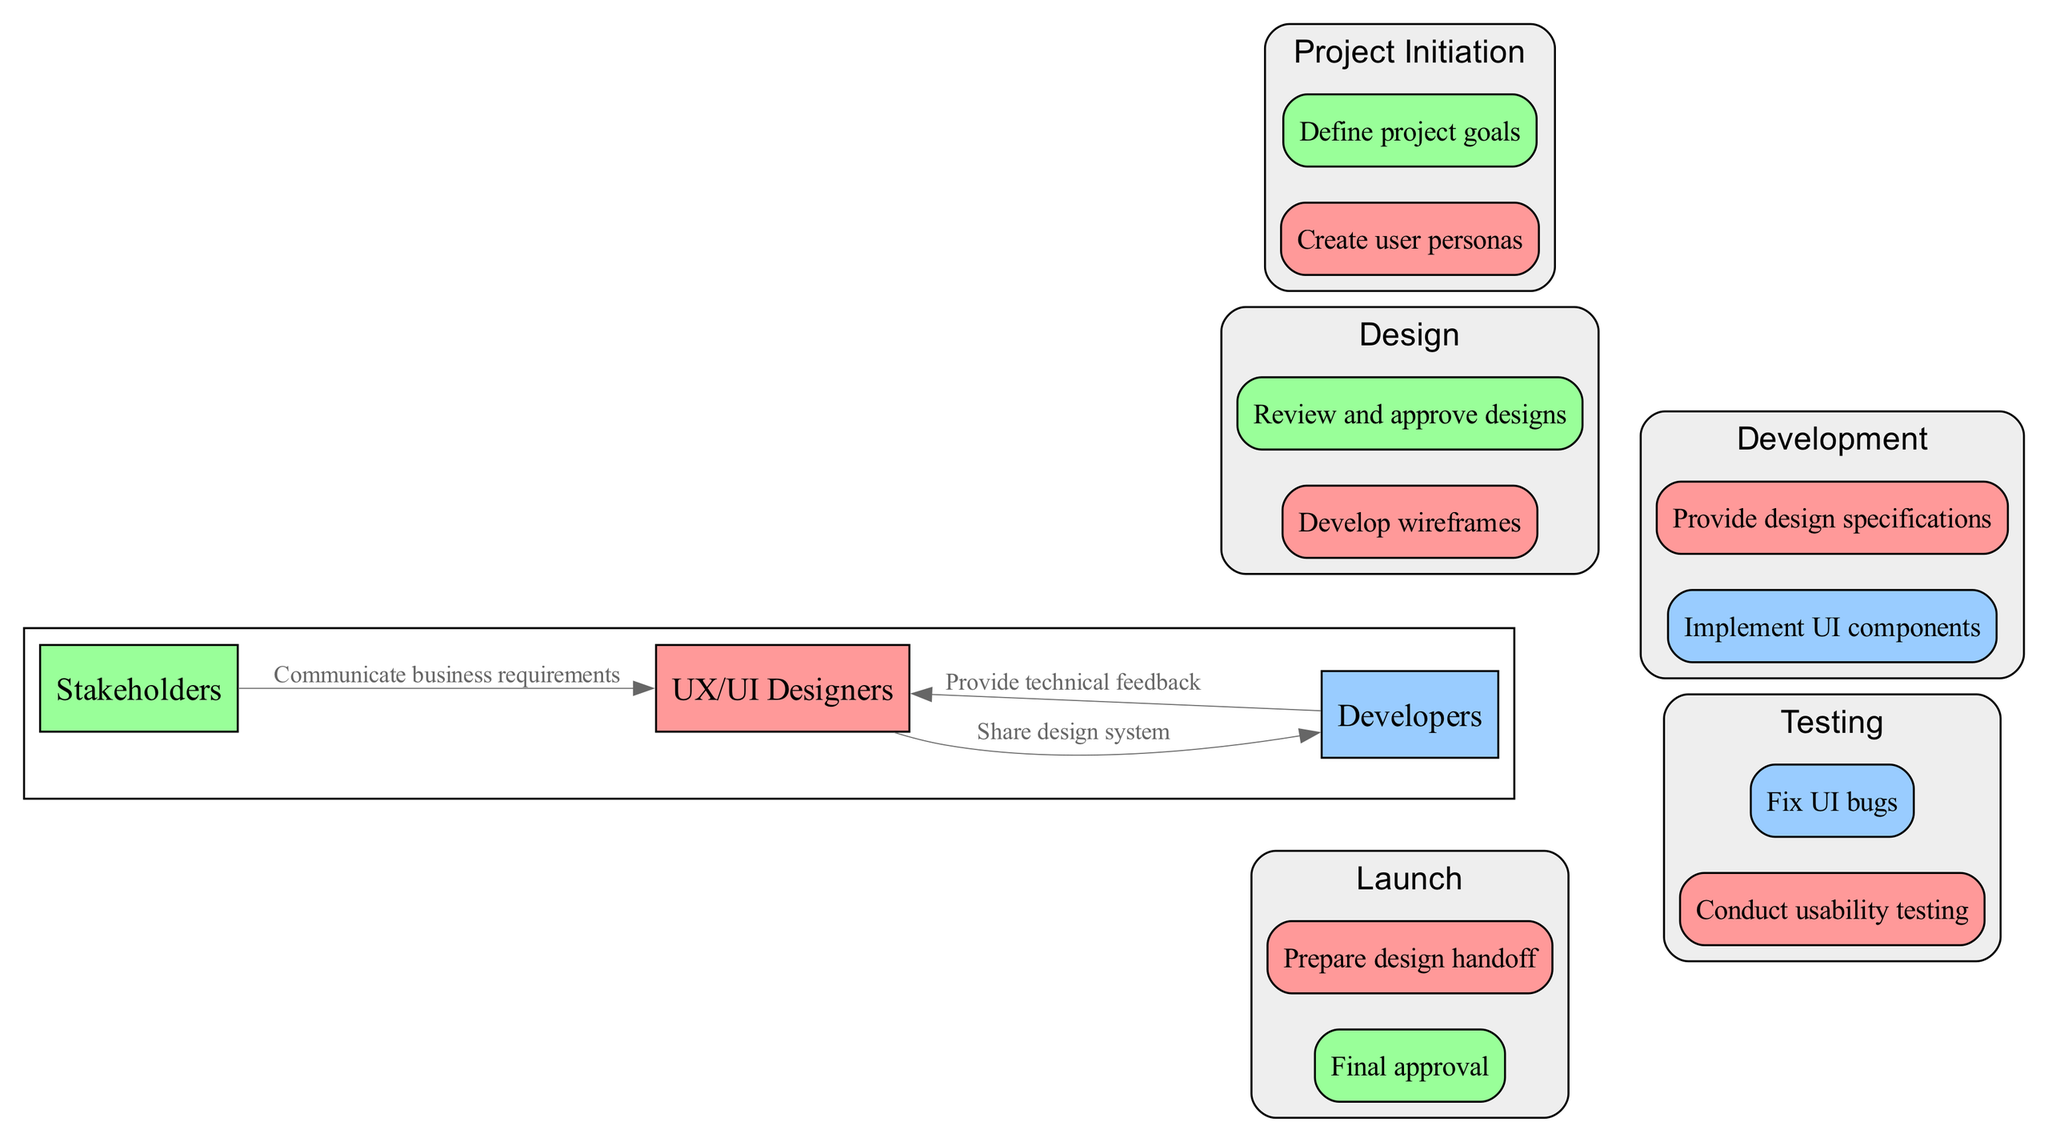What task is associated with the "Design" phase for UX/UI Designers? According to the diagram, the task associated with the "Design" phase for UX/UI Designers is "Develop wireframes," as it is listed under the tasks for that phase and lane.
Answer: Develop wireframes Who defines the project goals during the "Project Initiation" phase? The diagram indicates that "Stakeholders" are responsible for defining project goals in the "Project Initiation" phase, as they have a task specifically for this in that phase.
Answer: Stakeholders What action do UX/UI Designers take towards Developers during the Development phase? The diagram shows that UX/UI Designers share the design system with Developers during the Development phase, as indicated by the collaboration labeled between those two roles.
Answer: Share design system How many tasks are listed for the "Testing" phase? In the diagram, there are two tasks listed for the "Testing" phase: "Conduct usability testing" (by UX/UI Designers) and "Fix UI bugs" (by Developers). Thus, counting these tasks gives a total of two.
Answer: 2 Which team reviews and approves designs in the Design phase? Based on the diagram, the team that reviews and approves designs in the Design phase is "Stakeholders," as this task is explicitly assigned to them for this phase.
Answer: Stakeholders What is the last task performed before the Launch phase? Looking at the diagram, the last task performed before the Launch phase is "Conduct usability testing," as it is situated at the end of the Testing phase.
Answer: Conduct usability testing What is the connection between Stakeholders and UX/UI Designers regarding business requirements? The diagram represents a collaboration where Stakeholders communicate business requirements to UX/UI Designers, which highlights their interaction during the project's progression.
Answer: Communicate business requirements How many lanes are represented in the swimlane diagram? The diagram features three lanes: "UX/UI Designers," "Developers," and "Stakeholders," which can be directly counted from the lanes section of the swimlane diagram.
Answer: 3 